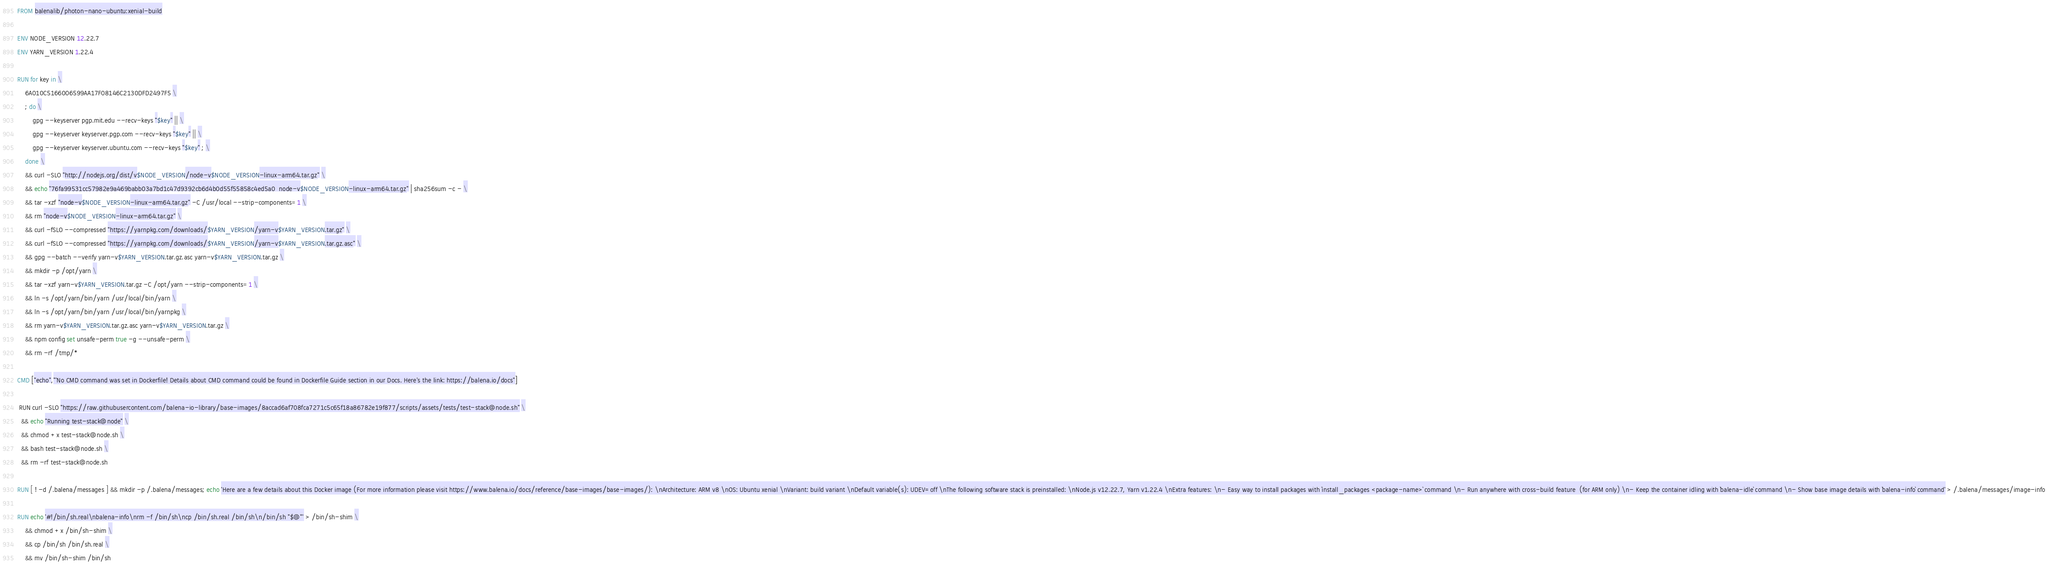<code> <loc_0><loc_0><loc_500><loc_500><_Dockerfile_>FROM balenalib/photon-nano-ubuntu:xenial-build

ENV NODE_VERSION 12.22.7
ENV YARN_VERSION 1.22.4

RUN for key in \
	6A010C5166006599AA17F08146C2130DFD2497F5 \
	; do \
		gpg --keyserver pgp.mit.edu --recv-keys "$key" || \
		gpg --keyserver keyserver.pgp.com --recv-keys "$key" || \
		gpg --keyserver keyserver.ubuntu.com --recv-keys "$key" ; \
	done \
	&& curl -SLO "http://nodejs.org/dist/v$NODE_VERSION/node-v$NODE_VERSION-linux-arm64.tar.gz" \
	&& echo "76fa99531cc57982e9a469babb03a7bd1c47d9392cb6d4b0d55f55858c4ed5a0  node-v$NODE_VERSION-linux-arm64.tar.gz" | sha256sum -c - \
	&& tar -xzf "node-v$NODE_VERSION-linux-arm64.tar.gz" -C /usr/local --strip-components=1 \
	&& rm "node-v$NODE_VERSION-linux-arm64.tar.gz" \
	&& curl -fSLO --compressed "https://yarnpkg.com/downloads/$YARN_VERSION/yarn-v$YARN_VERSION.tar.gz" \
	&& curl -fSLO --compressed "https://yarnpkg.com/downloads/$YARN_VERSION/yarn-v$YARN_VERSION.tar.gz.asc" \
	&& gpg --batch --verify yarn-v$YARN_VERSION.tar.gz.asc yarn-v$YARN_VERSION.tar.gz \
	&& mkdir -p /opt/yarn \
	&& tar -xzf yarn-v$YARN_VERSION.tar.gz -C /opt/yarn --strip-components=1 \
	&& ln -s /opt/yarn/bin/yarn /usr/local/bin/yarn \
	&& ln -s /opt/yarn/bin/yarn /usr/local/bin/yarnpkg \
	&& rm yarn-v$YARN_VERSION.tar.gz.asc yarn-v$YARN_VERSION.tar.gz \
	&& npm config set unsafe-perm true -g --unsafe-perm \
	&& rm -rf /tmp/*

CMD ["echo","'No CMD command was set in Dockerfile! Details about CMD command could be found in Dockerfile Guide section in our Docs. Here's the link: https://balena.io/docs"]

 RUN curl -SLO "https://raw.githubusercontent.com/balena-io-library/base-images/8accad6af708fca7271c5c65f18a86782e19f877/scripts/assets/tests/test-stack@node.sh" \
  && echo "Running test-stack@node" \
  && chmod +x test-stack@node.sh \
  && bash test-stack@node.sh \
  && rm -rf test-stack@node.sh 

RUN [ ! -d /.balena/messages ] && mkdir -p /.balena/messages; echo 'Here are a few details about this Docker image (For more information please visit https://www.balena.io/docs/reference/base-images/base-images/): \nArchitecture: ARM v8 \nOS: Ubuntu xenial \nVariant: build variant \nDefault variable(s): UDEV=off \nThe following software stack is preinstalled: \nNode.js v12.22.7, Yarn v1.22.4 \nExtra features: \n- Easy way to install packages with `install_packages <package-name>` command \n- Run anywhere with cross-build feature  (for ARM only) \n- Keep the container idling with `balena-idle` command \n- Show base image details with `balena-info` command' > /.balena/messages/image-info

RUN echo '#!/bin/sh.real\nbalena-info\nrm -f /bin/sh\ncp /bin/sh.real /bin/sh\n/bin/sh "$@"' > /bin/sh-shim \
	&& chmod +x /bin/sh-shim \
	&& cp /bin/sh /bin/sh.real \
	&& mv /bin/sh-shim /bin/sh</code> 